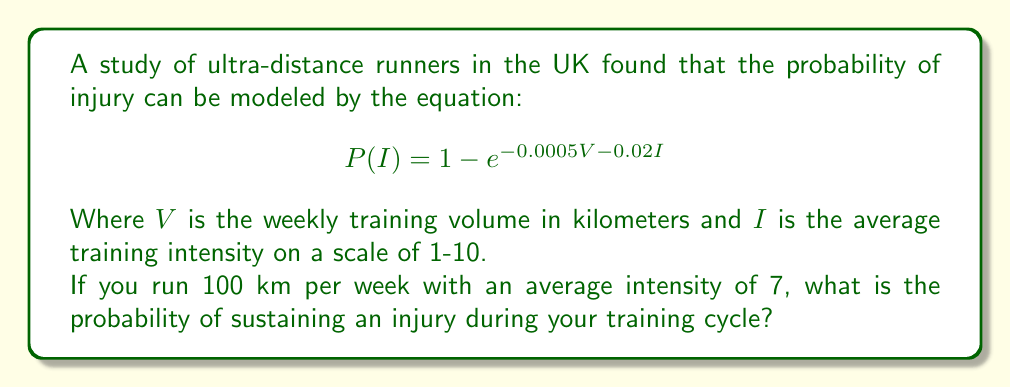Give your solution to this math problem. Let's approach this step-by-step:

1) We are given the probability model:
   $$P(I) = 1 - e^{-0.0005V - 0.02I}$$

2) We know the following values:
   $V = 100$ km (weekly training volume)
   $I = 7$ (average training intensity)

3) Let's substitute these values into our equation:
   $$P(I) = 1 - e^{-0.0005(100) - 0.02(7)}$$

4) First, let's calculate the exponent:
   $$-0.0005(100) - 0.02(7) = -0.05 - 0.14 = -0.19$$

5) Now our equation looks like this:
   $$P(I) = 1 - e^{-0.19}$$

6) Calculate $e^{-0.19}$:
   $$e^{-0.19} \approx 0.8269$$

7) Finally, subtract this from 1:
   $$P(I) = 1 - 0.8269 \approx 0.1731$$

8) Convert to a percentage:
   $$0.1731 \times 100\% = 17.31\%$$
Answer: 17.31% 